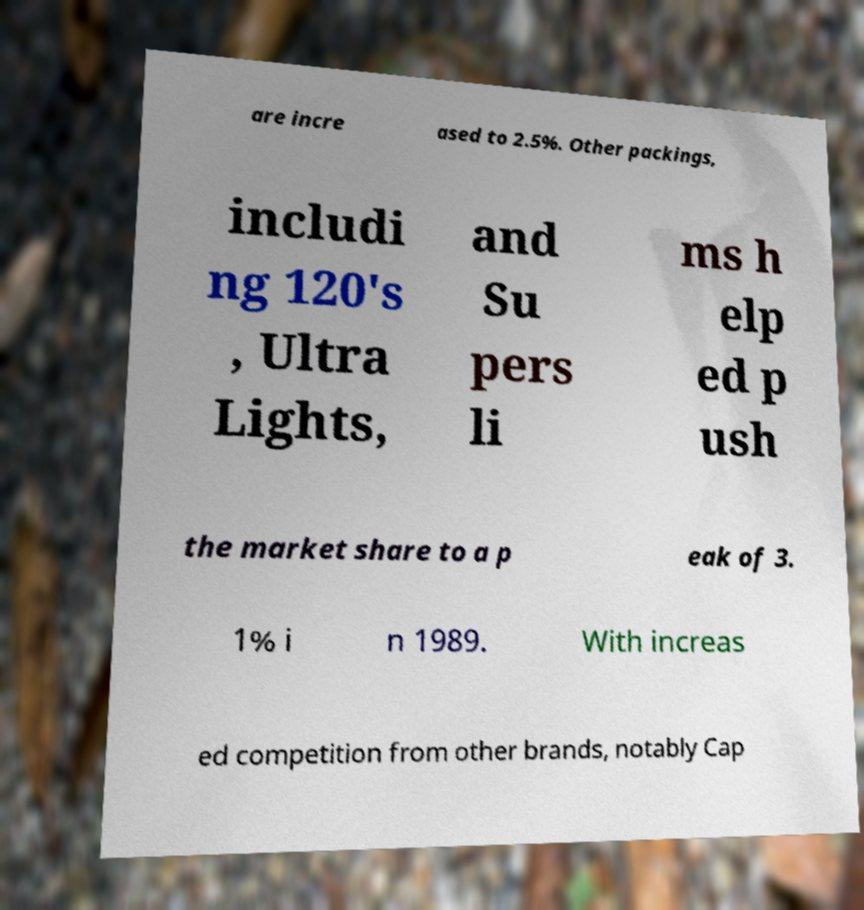I need the written content from this picture converted into text. Can you do that? are incre ased to 2.5%. Other packings, includi ng 120's , Ultra Lights, and Su pers li ms h elp ed p ush the market share to a p eak of 3. 1% i n 1989. With increas ed competition from other brands, notably Cap 